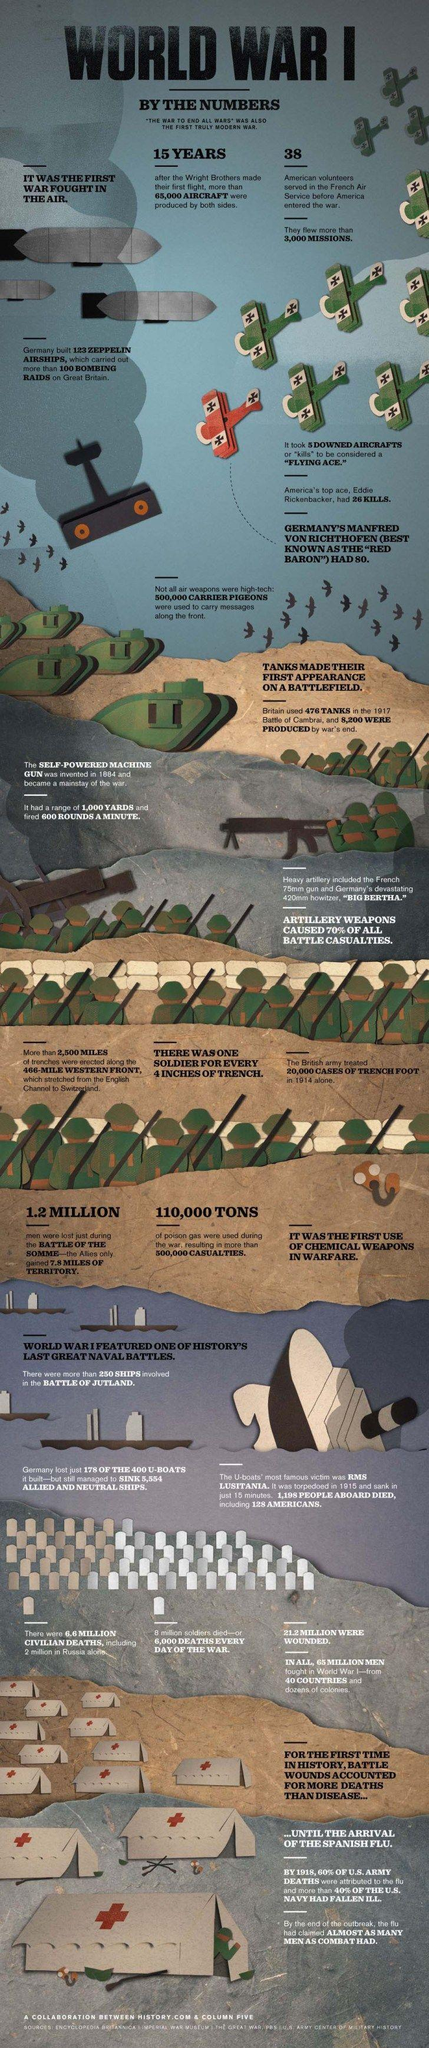By 1918 what had caused majority of the American army deaths?
Answer the question with a short phrase. Spanish flu How many tanks were used in the Battle of Cambrai? 476 Who was America's flying ace? Eddie Rickenbacker How many kills were needed to be considered a flying Ace? 5 Which weapon could fire 600 rounds in one minute? Self-powered machine gun How many men participated in the war? 65 million By the end of the war how many tanks were produced? 8,200 How many ships were sunk by the German u-boats? 5,554 How many were wounded in the war? 21.2 million How much poison gas was used during the war? 110,000 tons How many of the German u-boats were destroyed? 178 Who was called the red baron and how many kills did he have? Manfred Von Richthofen, 80 How many Americans volunteered in the French air service before America entered the war? 38 What was the number of civilian deaths? 6.6 million Out of the 400 German u-boats how many were there after the war? 222 What was the range of a self powered machine gun? 1,000 yards What was used to carry messages along the front? Carrier pigeons How many lives were lost in the Battle of Somme? 1.2 million What was the number of civilian deaths in Russia? 2 million What was the number of deaths per day during the war? 6,000 How many casualties were caused due to the poison gas? 500,000 